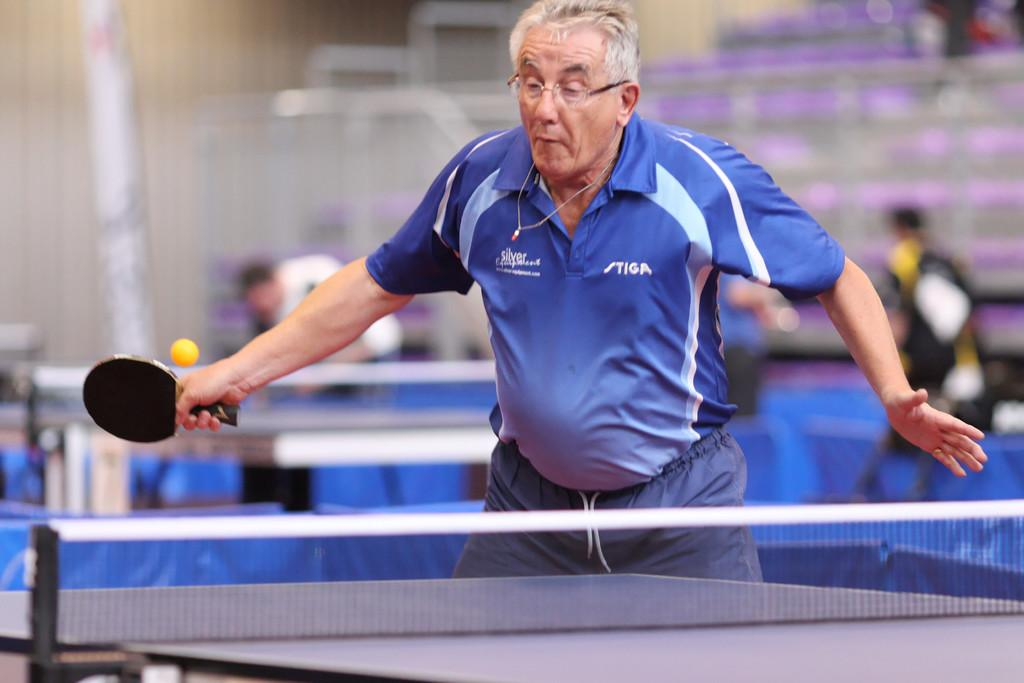Who is the main subject in the image? There is an old man in the image. What is the old man doing in the image? The old man is playing table tennis. Is the old man playing table tennis alone? No, there is at least one other person playing table tennis with the old man. Can you see any deer or nests in the image? No, there are no deer or nests present in the image. 